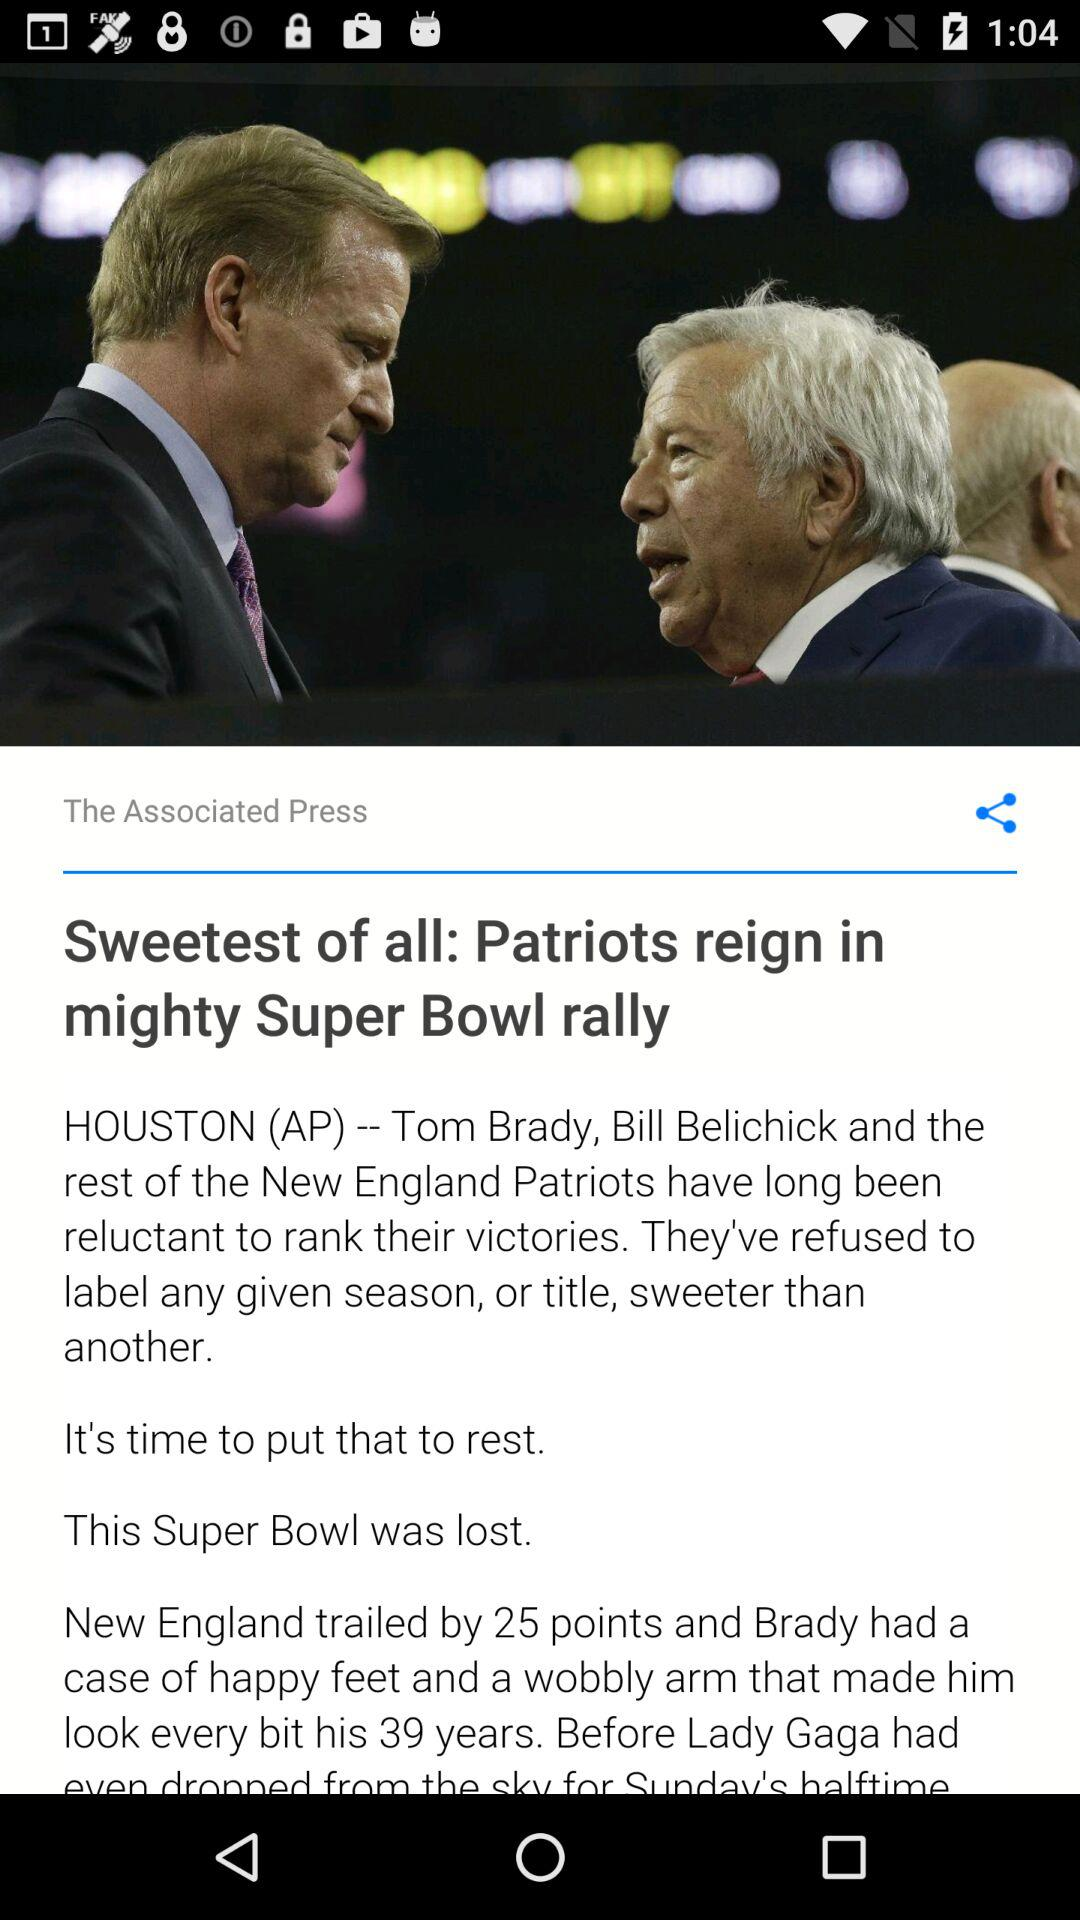What is the headline? The headline is "Sweetest of all: Patriots reign in mighty Super Bowl rally". 